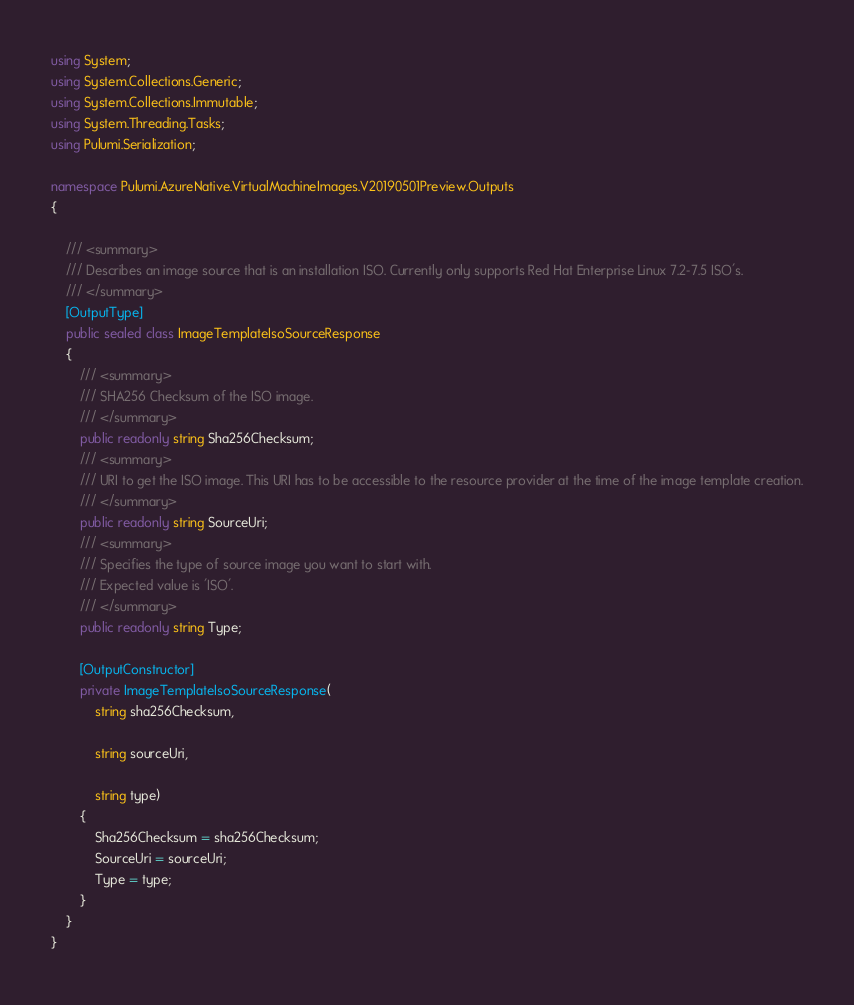<code> <loc_0><loc_0><loc_500><loc_500><_C#_>
using System;
using System.Collections.Generic;
using System.Collections.Immutable;
using System.Threading.Tasks;
using Pulumi.Serialization;

namespace Pulumi.AzureNative.VirtualMachineImages.V20190501Preview.Outputs
{

    /// <summary>
    /// Describes an image source that is an installation ISO. Currently only supports Red Hat Enterprise Linux 7.2-7.5 ISO's.
    /// </summary>
    [OutputType]
    public sealed class ImageTemplateIsoSourceResponse
    {
        /// <summary>
        /// SHA256 Checksum of the ISO image.
        /// </summary>
        public readonly string Sha256Checksum;
        /// <summary>
        /// URI to get the ISO image. This URI has to be accessible to the resource provider at the time of the image template creation.
        /// </summary>
        public readonly string SourceUri;
        /// <summary>
        /// Specifies the type of source image you want to start with.
        /// Expected value is 'ISO'.
        /// </summary>
        public readonly string Type;

        [OutputConstructor]
        private ImageTemplateIsoSourceResponse(
            string sha256Checksum,

            string sourceUri,

            string type)
        {
            Sha256Checksum = sha256Checksum;
            SourceUri = sourceUri;
            Type = type;
        }
    }
}
</code> 